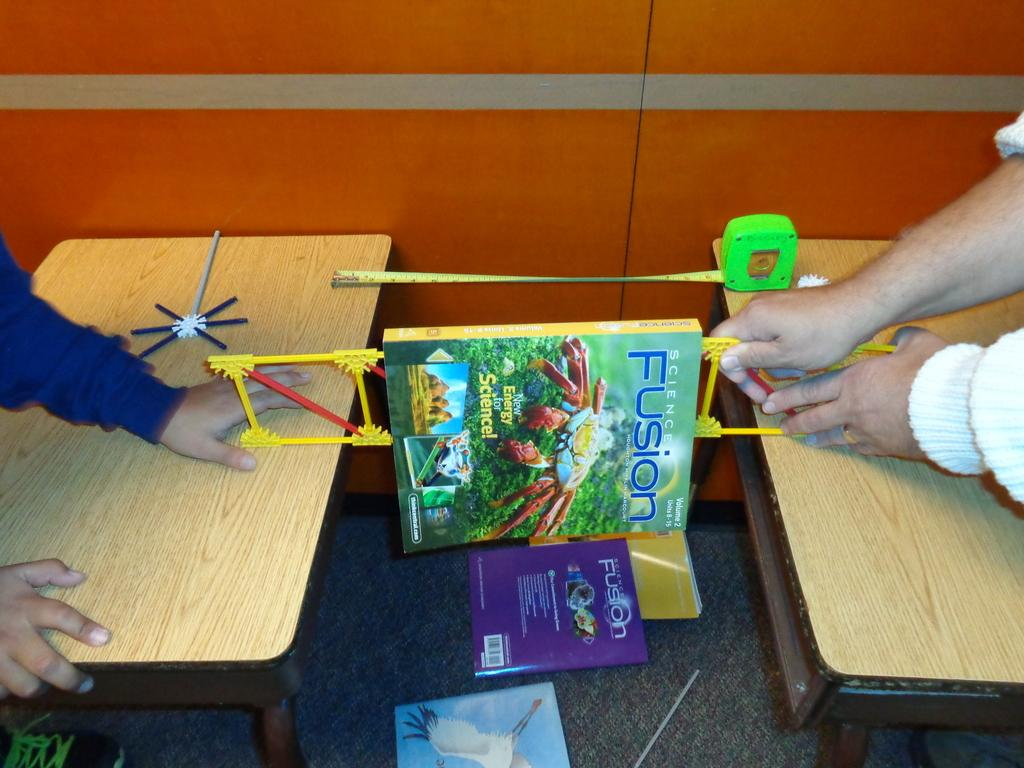<image>
Summarize the visual content of the image. A book that is called Science Fusion and has a crab on it. 